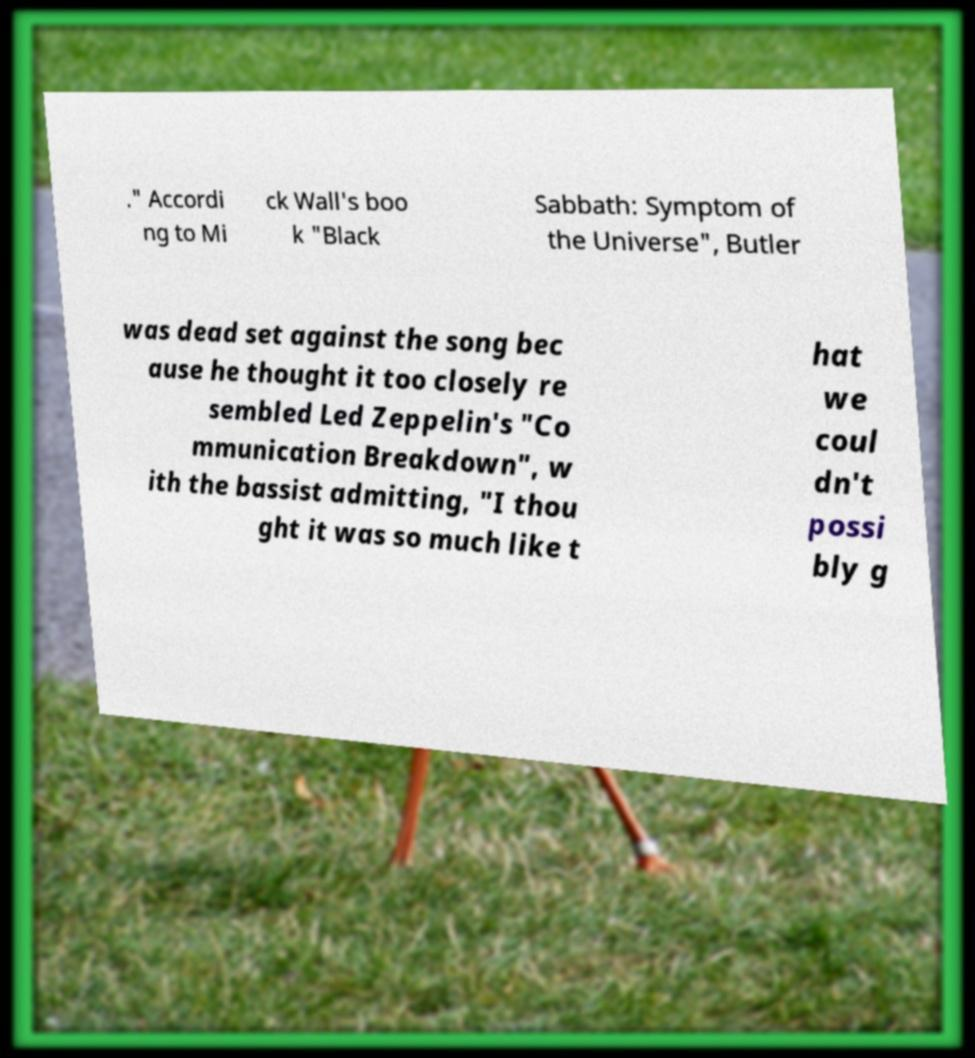Please read and relay the text visible in this image. What does it say? ." Accordi ng to Mi ck Wall's boo k "Black Sabbath: Symptom of the Universe", Butler was dead set against the song bec ause he thought it too closely re sembled Led Zeppelin's "Co mmunication Breakdown", w ith the bassist admitting, "I thou ght it was so much like t hat we coul dn't possi bly g 